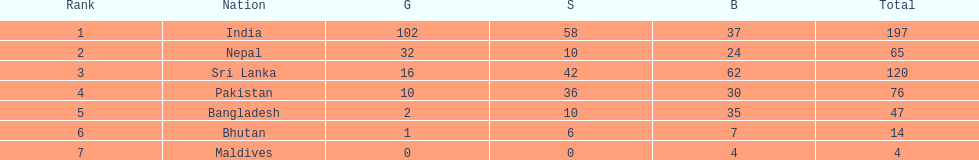Which nations played at the 1999 south asian games? India, Nepal, Sri Lanka, Pakistan, Bangladesh, Bhutan, Maldives. Which country is listed second in the table? Nepal. 